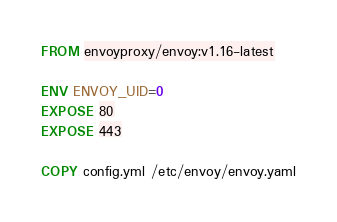<code> <loc_0><loc_0><loc_500><loc_500><_Dockerfile_>FROM envoyproxy/envoy:v1.16-latest

ENV ENVOY_UID=0
EXPOSE 80
EXPOSE 443

COPY config.yml /etc/envoy/envoy.yaml
</code> 